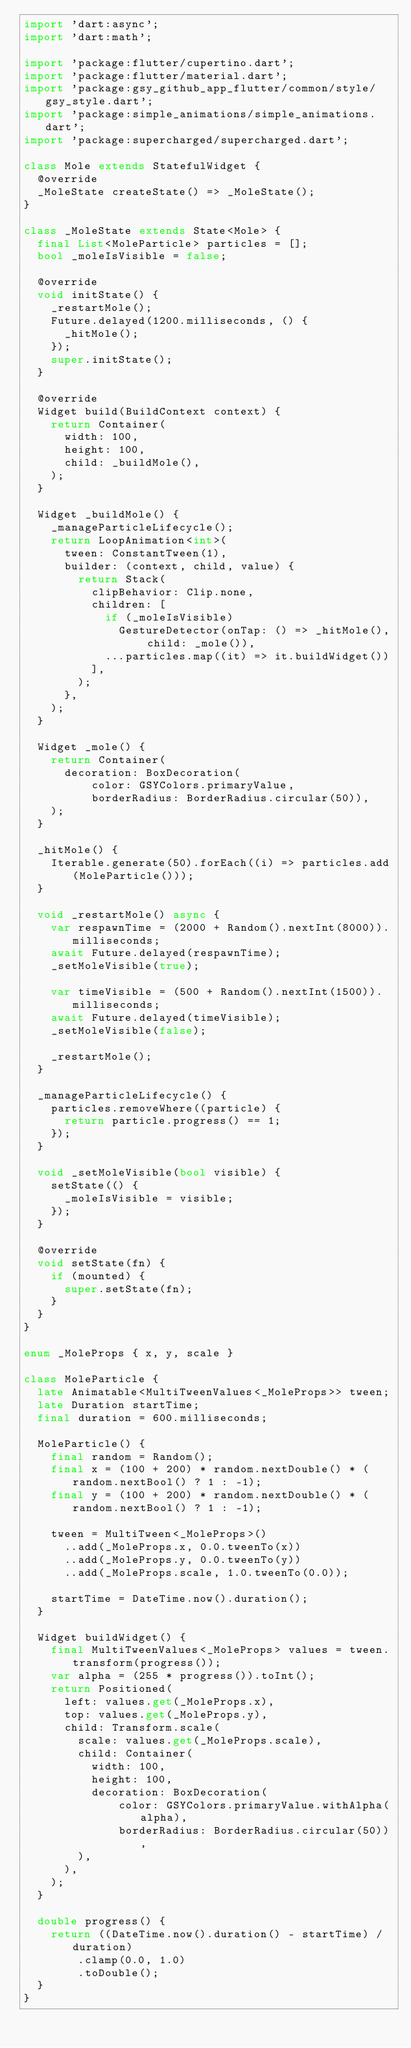Convert code to text. <code><loc_0><loc_0><loc_500><loc_500><_Dart_>import 'dart:async';
import 'dart:math';

import 'package:flutter/cupertino.dart';
import 'package:flutter/material.dart';
import 'package:gsy_github_app_flutter/common/style/gsy_style.dart';
import 'package:simple_animations/simple_animations.dart';
import 'package:supercharged/supercharged.dart';

class Mole extends StatefulWidget {
  @override
  _MoleState createState() => _MoleState();
}

class _MoleState extends State<Mole> {
  final List<MoleParticle> particles = [];
  bool _moleIsVisible = false;

  @override
  void initState() {
    _restartMole();
    Future.delayed(1200.milliseconds, () {
      _hitMole();
    });
    super.initState();
  }

  @override
  Widget build(BuildContext context) {
    return Container(
      width: 100,
      height: 100,
      child: _buildMole(),
    );
  }

  Widget _buildMole() {
    _manageParticleLifecycle();
    return LoopAnimation<int>(
      tween: ConstantTween(1),
      builder: (context, child, value) {
        return Stack(
          clipBehavior: Clip.none,
          children: [
            if (_moleIsVisible)
              GestureDetector(onTap: () => _hitMole(), child: _mole()),
            ...particles.map((it) => it.buildWidget())
          ],
        );
      },
    );
  }

  Widget _mole() {
    return Container(
      decoration: BoxDecoration(
          color: GSYColors.primaryValue,
          borderRadius: BorderRadius.circular(50)),
    );
  }

  _hitMole() {
    Iterable.generate(50).forEach((i) => particles.add(MoleParticle()));
  }

  void _restartMole() async {
    var respawnTime = (2000 + Random().nextInt(8000)).milliseconds;
    await Future.delayed(respawnTime);
    _setMoleVisible(true);

    var timeVisible = (500 + Random().nextInt(1500)).milliseconds;
    await Future.delayed(timeVisible);
    _setMoleVisible(false);

    _restartMole();
  }

  _manageParticleLifecycle() {
    particles.removeWhere((particle) {
      return particle.progress() == 1;
    });
  }

  void _setMoleVisible(bool visible) {
    setState(() {
      _moleIsVisible = visible;
    });
  }

  @override
  void setState(fn) {
    if (mounted) {
      super.setState(fn);
    }
  }
}

enum _MoleProps { x, y, scale }

class MoleParticle {
  late Animatable<MultiTweenValues<_MoleProps>> tween;
  late Duration startTime;
  final duration = 600.milliseconds;

  MoleParticle() {
    final random = Random();
    final x = (100 + 200) * random.nextDouble() * (random.nextBool() ? 1 : -1);
    final y = (100 + 200) * random.nextDouble() * (random.nextBool() ? 1 : -1);

    tween = MultiTween<_MoleProps>()
      ..add(_MoleProps.x, 0.0.tweenTo(x))
      ..add(_MoleProps.y, 0.0.tweenTo(y))
      ..add(_MoleProps.scale, 1.0.tweenTo(0.0));

    startTime = DateTime.now().duration();
  }

  Widget buildWidget() {
    final MultiTweenValues<_MoleProps> values = tween.transform(progress());
    var alpha = (255 * progress()).toInt();
    return Positioned(
      left: values.get(_MoleProps.x),
      top: values.get(_MoleProps.y),
      child: Transform.scale(
        scale: values.get(_MoleProps.scale),
        child: Container(
          width: 100,
          height: 100,
          decoration: BoxDecoration(
              color: GSYColors.primaryValue.withAlpha(alpha),
              borderRadius: BorderRadius.circular(50)),
        ),
      ),
    );
  }

  double progress() {
    return ((DateTime.now().duration() - startTime) / duration)
        .clamp(0.0, 1.0)
        .toDouble();
  }
}
</code> 